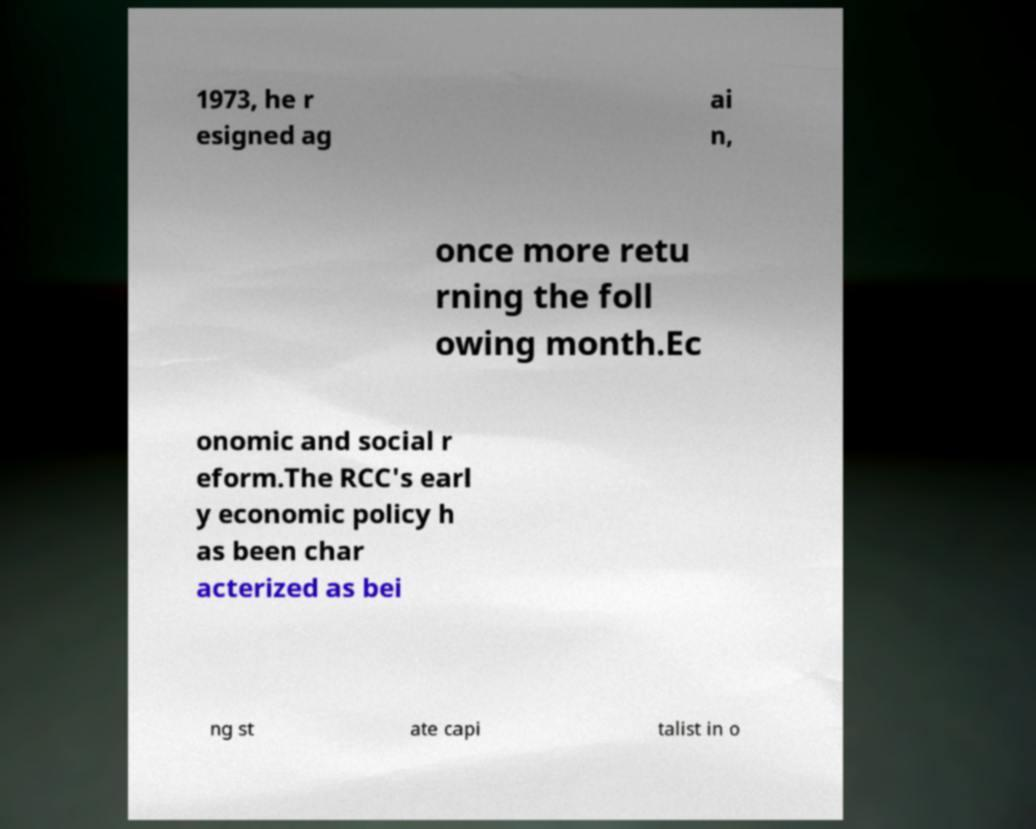I need the written content from this picture converted into text. Can you do that? 1973, he r esigned ag ai n, once more retu rning the foll owing month.Ec onomic and social r eform.The RCC's earl y economic policy h as been char acterized as bei ng st ate capi talist in o 